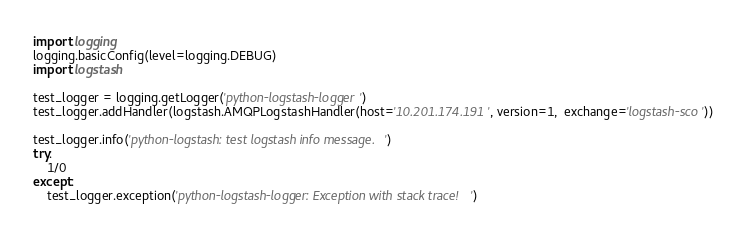Convert code to text. <code><loc_0><loc_0><loc_500><loc_500><_Python_>import logging
logging.basicConfig(level=logging.DEBUG)
import logstash

test_logger = logging.getLogger('python-logstash-logger')
test_logger.addHandler(logstash.AMQPLogstashHandler(host='10.201.174.191', version=1,  exchange='logstash-sco'))

test_logger.info('python-logstash: test logstash info message.')
try:
    1/0
except:
    test_logger.exception('python-logstash-logger: Exception with stack trace!')
</code> 